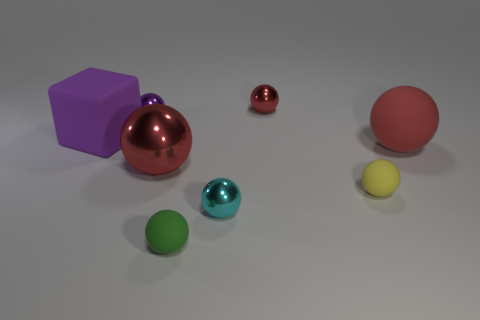What number of things are either metallic spheres behind the red rubber ball or purple spheres?
Offer a terse response. 2. What material is the purple ball?
Offer a very short reply. Metal. Do the matte block and the cyan thing have the same size?
Offer a terse response. No. What number of spheres are either yellow objects or purple matte things?
Make the answer very short. 1. The tiny ball that is in front of the tiny metallic object in front of the yellow rubber object is what color?
Your answer should be very brief. Green. Are there fewer green balls left of the large purple thing than red metal things that are behind the red rubber ball?
Your answer should be compact. Yes. There is a red matte sphere; is its size the same as the red ball that is left of the cyan metallic ball?
Your response must be concise. Yes. There is a object that is to the right of the big purple rubber cube and left of the big red metal ball; what shape is it?
Provide a succinct answer. Sphere. There is a red sphere that is the same material as the tiny green ball; what size is it?
Your answer should be very brief. Large. There is a small metal sphere that is in front of the rubber block; what number of purple balls are in front of it?
Ensure brevity in your answer.  0. 